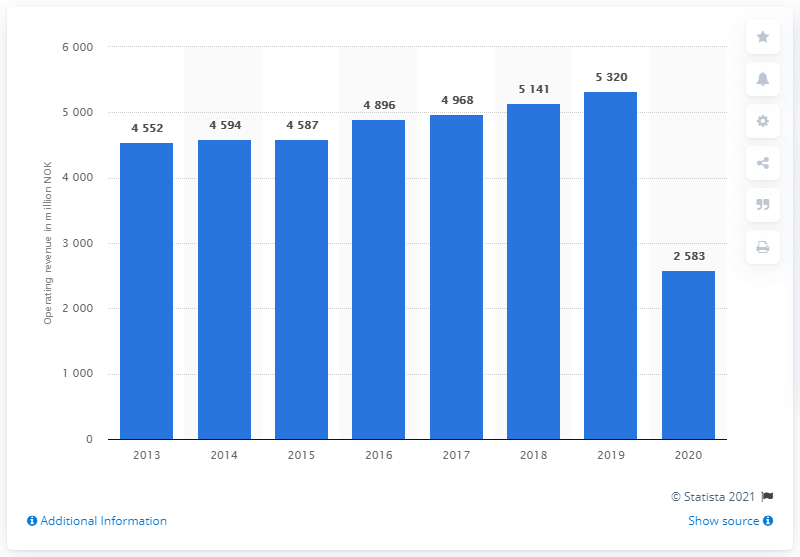Indicate a few pertinent items in this graphic. In 2019, the number of days between the first day of school to the last day of school was higher than in 2020 by 2737 days. Color Line's revenue in 2020 was approximately 2,583. In the year 2018, the value is 5141. 